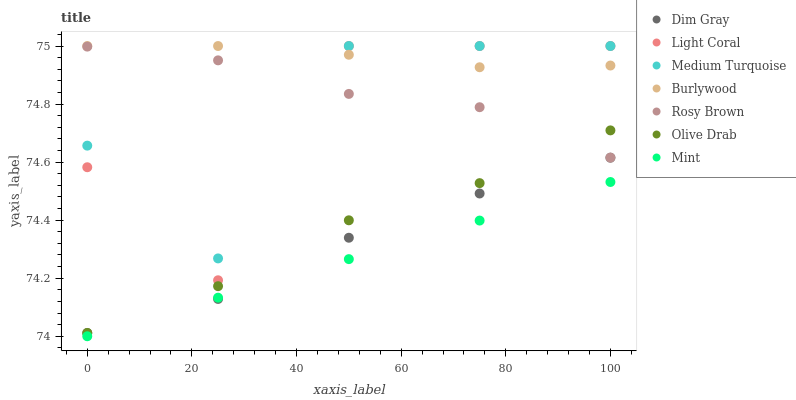Does Mint have the minimum area under the curve?
Answer yes or no. Yes. Does Burlywood have the maximum area under the curve?
Answer yes or no. Yes. Does Rosy Brown have the minimum area under the curve?
Answer yes or no. No. Does Rosy Brown have the maximum area under the curve?
Answer yes or no. No. Is Mint the smoothest?
Answer yes or no. Yes. Is Light Coral the roughest?
Answer yes or no. Yes. Is Burlywood the smoothest?
Answer yes or no. No. Is Burlywood the roughest?
Answer yes or no. No. Does Mint have the lowest value?
Answer yes or no. Yes. Does Rosy Brown have the lowest value?
Answer yes or no. No. Does Medium Turquoise have the highest value?
Answer yes or no. Yes. Does Rosy Brown have the highest value?
Answer yes or no. No. Is Mint less than Medium Turquoise?
Answer yes or no. Yes. Is Medium Turquoise greater than Mint?
Answer yes or no. Yes. Does Olive Drab intersect Rosy Brown?
Answer yes or no. Yes. Is Olive Drab less than Rosy Brown?
Answer yes or no. No. Is Olive Drab greater than Rosy Brown?
Answer yes or no. No. Does Mint intersect Medium Turquoise?
Answer yes or no. No. 